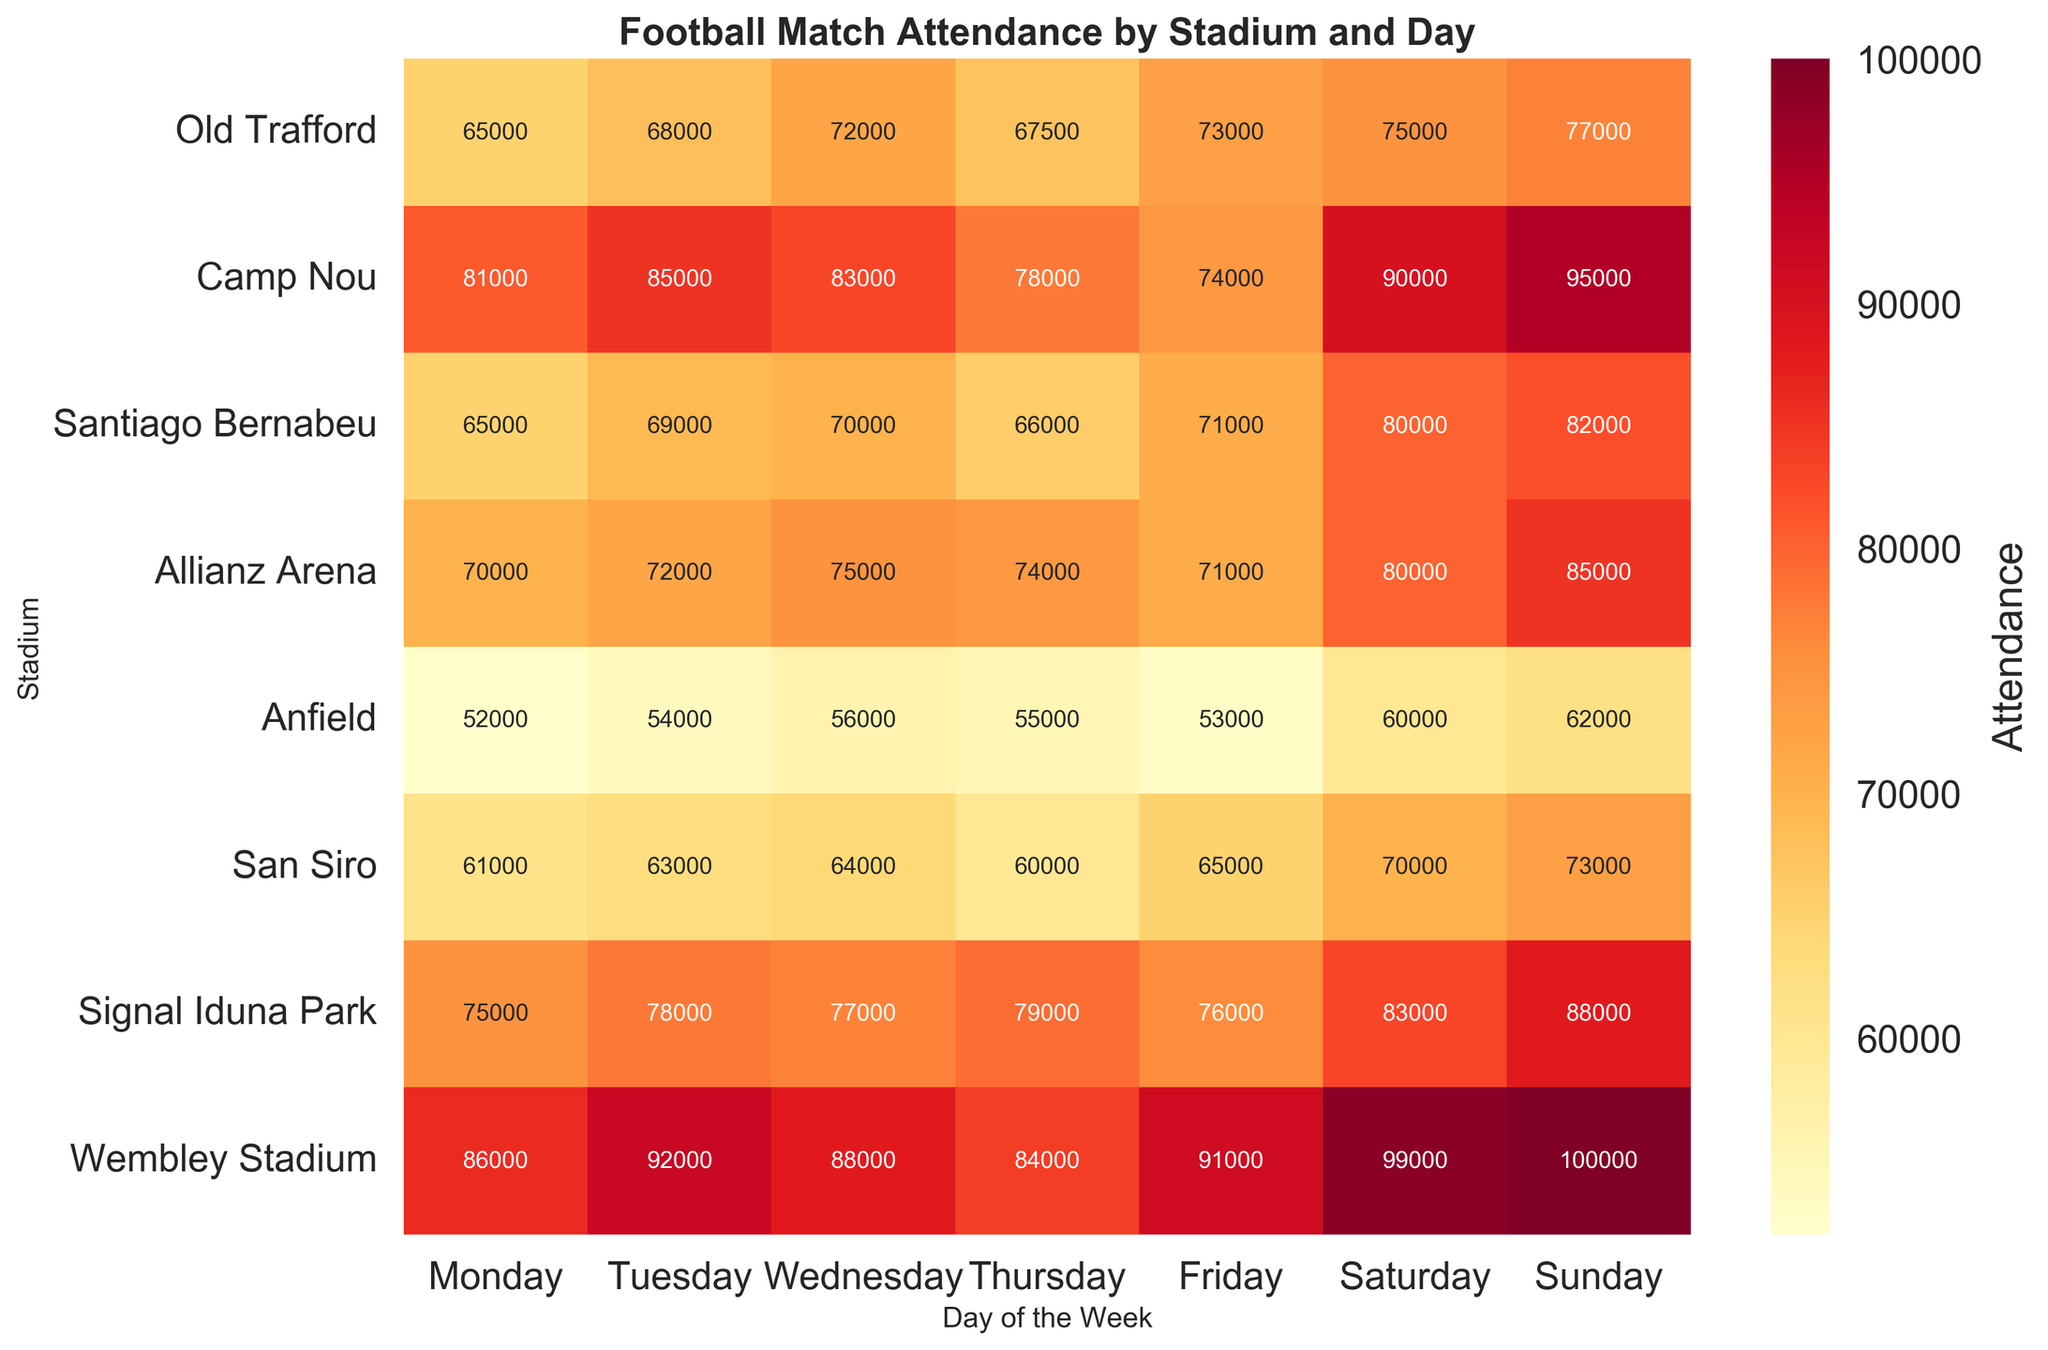What is the title of the figure? The title can be found at the top of the heatmap, which describes the content of the figure.
Answer: Football Match Attendance by Stadium and Day Which stadium has the highest attendance on Sunday? Look at the intersection of the "Sunday" column and find the maximum value.
Answer: Wembley Stadium How many stadiums have an attendance of 80,000 or more on Friday? Count all cells in the "Friday" column that have a value of 80,000 or more.
Answer: Three (Camp Nou, Santiago Bernabeu, Signal Iduna Park) Which day generally has the highest attendance across all stadiums? Calculate the average attendance for each day and identify the highest.
Answer: Sunday What is the total attendance at Old Trafford for the entire week? Add up the attendance figures for Old Trafford across all days. 65000 + 68000 + 72000 + 67500 + 73000 + 75000 + 77000
Answer: 497,500 Compare the attendance of Allianz Arena and San Siro on Wednesday. Which stadium has more? Subtract the attendance of San Siro from that of Allianz Arena on Wednesday. 75000 - 64000
Answer: Allianz Arena by 11,000 What is the highest attendance recorded throughout the entire week? Identify the maximum value in the entire heatmap.
Answer: 100,000 On which day does Anfield have its lowest attendance? Find the minimum value in the Anfield row and identify the corresponding day.
Answer: Monday What is the average attendance at Camp Nou across Monday to Wednesday? Sum the attendances from Monday to Wednesday at Camp Nou and divide by 3. (81000 + 85000 + 83000) / 3
Answer: 83,667 Is the attendance at Wembley Stadium on Thursday more than that at Santiago Bernabeu on Sunday? Compare the attendance values of Wembley Stadium on Thursday and Santiago Bernabeu on Sunday. 84000 > 82000
Answer: Yes 